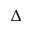Convert formula to latex. <formula><loc_0><loc_0><loc_500><loc_500>\Delta</formula> 